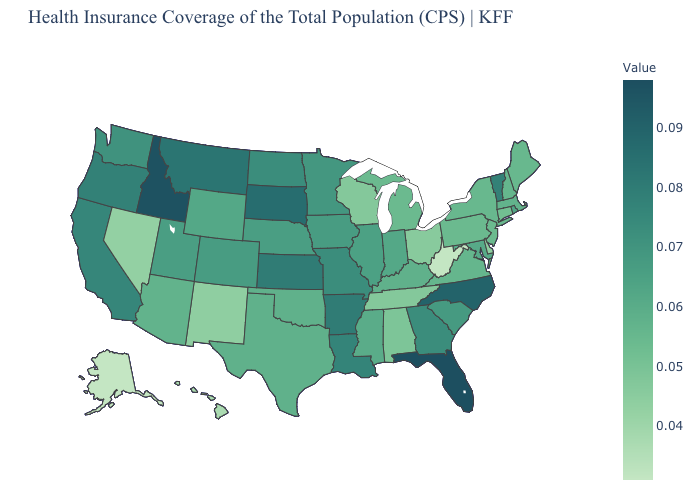Among the states that border Indiana , which have the lowest value?
Be succinct. Ohio. Does Michigan have the highest value in the MidWest?
Be succinct. No. Which states hav the highest value in the Northeast?
Concise answer only. Vermont. Which states have the highest value in the USA?
Keep it brief. Florida. Which states have the lowest value in the Northeast?
Keep it brief. Connecticut. 